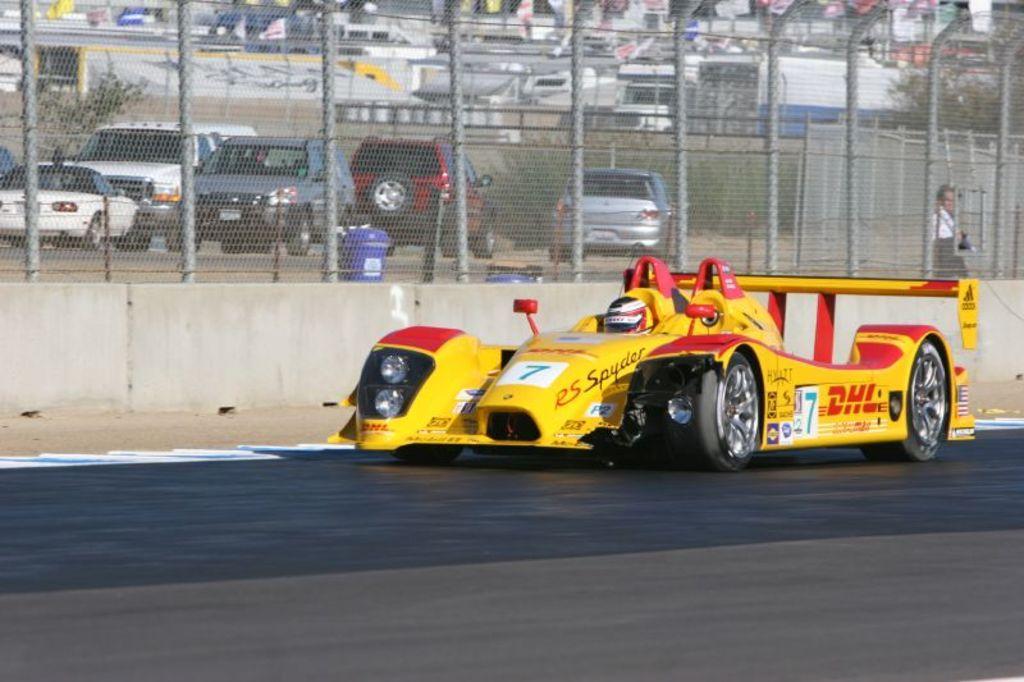Please provide a concise description of this image. In this image in front there is a car on the road. In the background of the image there is a metal fence. There is a person. There are dustbins. There are vehicles. There are flags, trees. 